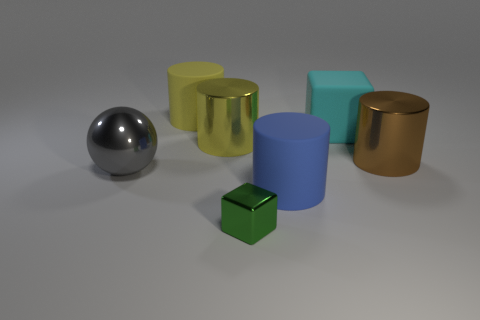Subtract all large yellow matte cylinders. How many cylinders are left? 3 Add 2 cyan shiny things. How many objects exist? 9 Subtract all cyan cubes. How many cubes are left? 1 Subtract 1 cylinders. How many cylinders are left? 3 Subtract all green balls. How many yellow cylinders are left? 2 Subtract all balls. Subtract all cylinders. How many objects are left? 2 Add 3 large gray spheres. How many large gray spheres are left? 4 Add 6 blue matte objects. How many blue matte objects exist? 7 Subtract 0 purple blocks. How many objects are left? 7 Subtract all cubes. How many objects are left? 5 